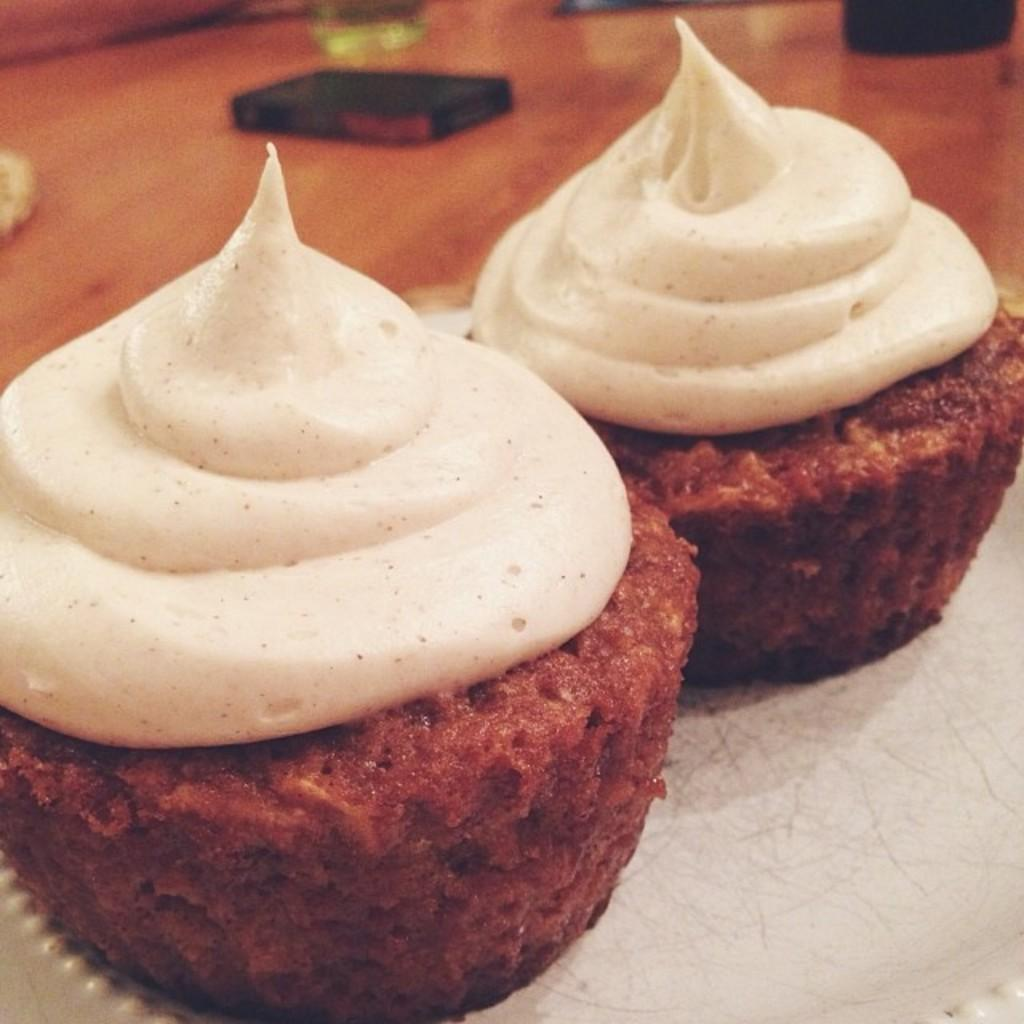What is on the plate in the image? There is food in a plate in the image. What is located near the plate? There is a mobile beside the plate. What else can be seen on the table in the image? There are other things on the table in the image. How many chairs are visible in the image? There is no information about chairs in the image, so we cannot determine the number of chairs. Can you describe the creature sitting on the plate in the image? There is no creature present on the plate in the image; it contains food. 